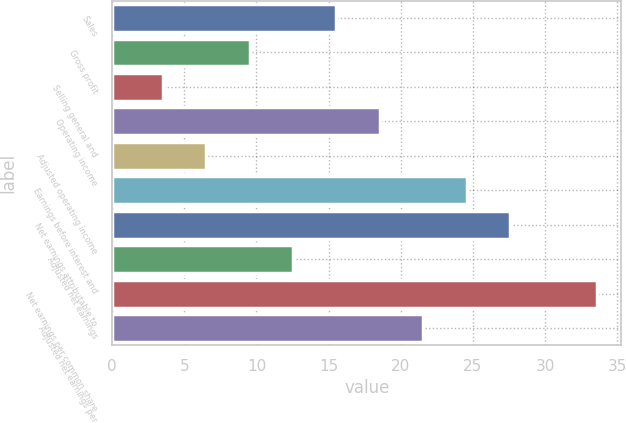Convert chart to OTSL. <chart><loc_0><loc_0><loc_500><loc_500><bar_chart><fcel>Sales<fcel>Gross profit<fcel>Selling general and<fcel>Operating income<fcel>Adjusted operating income<fcel>Earnings before interest and<fcel>Net earnings attributable to<fcel>Adjusted net earnings<fcel>Net earnings per common share<fcel>Adjusted net earnings per<nl><fcel>15.54<fcel>9.52<fcel>3.5<fcel>18.55<fcel>6.51<fcel>24.57<fcel>27.58<fcel>12.53<fcel>33.6<fcel>21.56<nl></chart> 